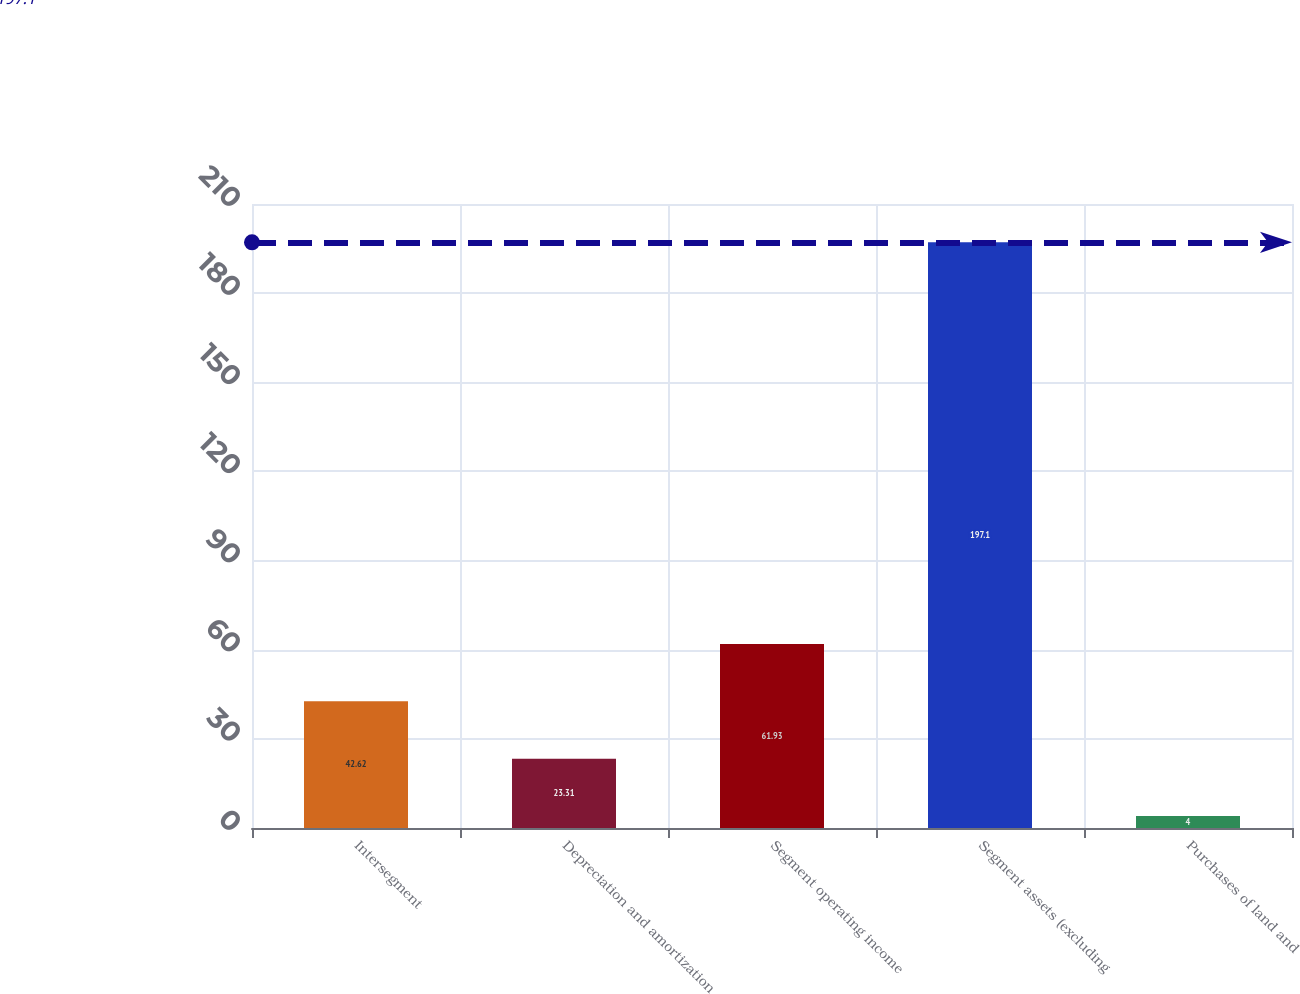Convert chart to OTSL. <chart><loc_0><loc_0><loc_500><loc_500><bar_chart><fcel>Intersegment<fcel>Depreciation and amortization<fcel>Segment operating income<fcel>Segment assets (excluding<fcel>Purchases of land and<nl><fcel>42.62<fcel>23.31<fcel>61.93<fcel>197.1<fcel>4<nl></chart> 